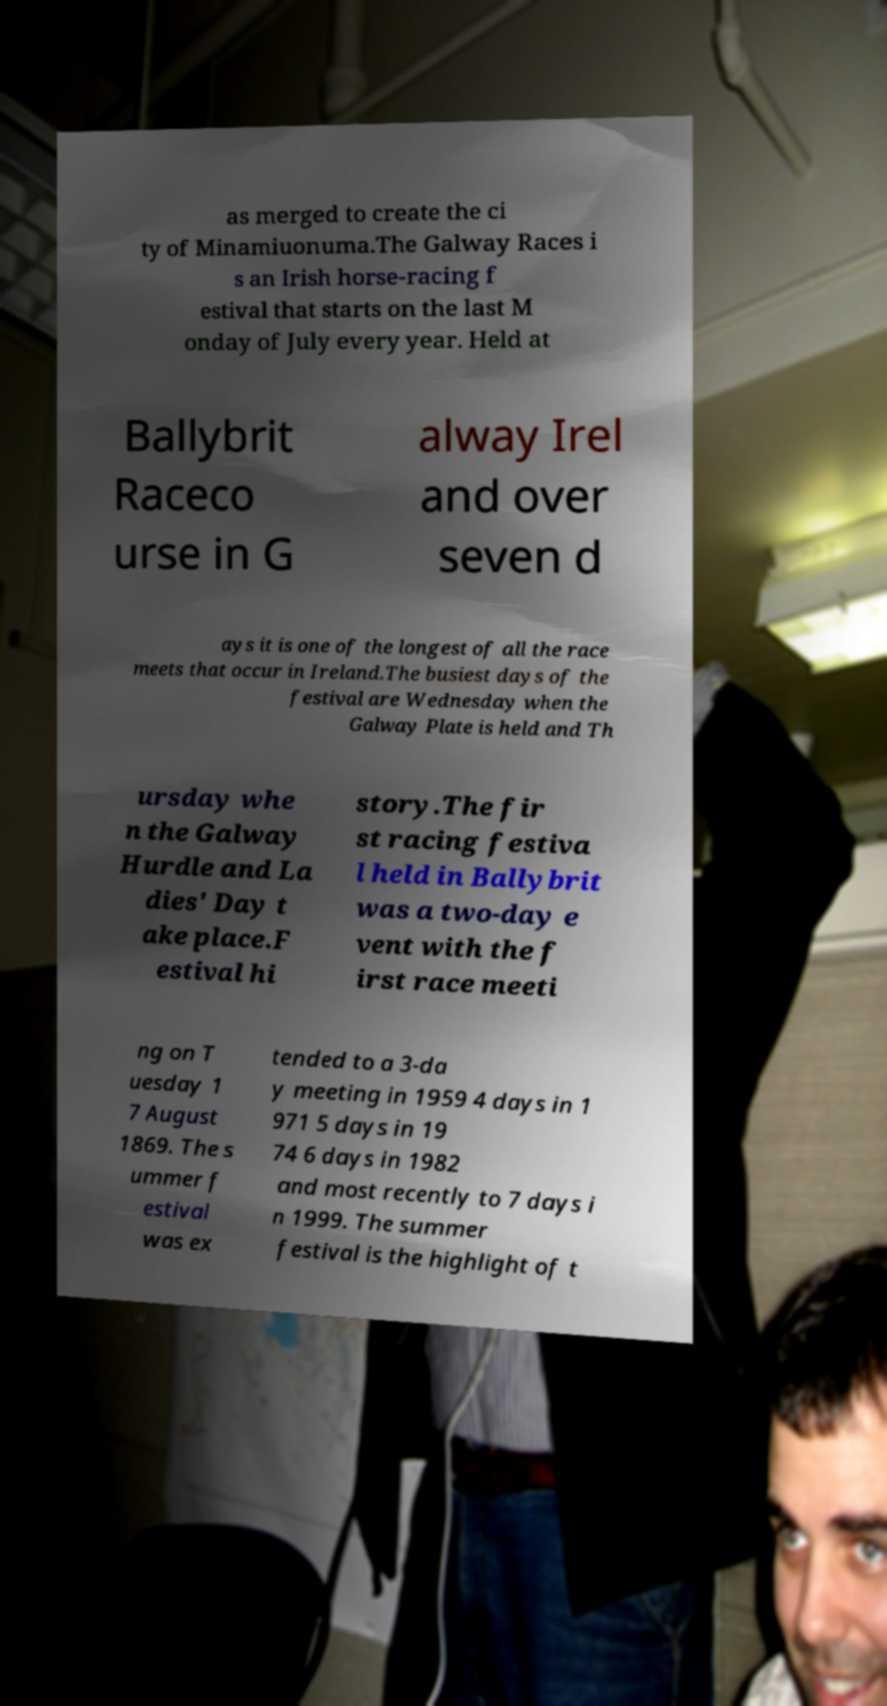There's text embedded in this image that I need extracted. Can you transcribe it verbatim? as merged to create the ci ty of Minamiuonuma.The Galway Races i s an Irish horse-racing f estival that starts on the last M onday of July every year. Held at Ballybrit Raceco urse in G alway Irel and over seven d ays it is one of the longest of all the race meets that occur in Ireland.The busiest days of the festival are Wednesday when the Galway Plate is held and Th ursday whe n the Galway Hurdle and La dies' Day t ake place.F estival hi story.The fir st racing festiva l held in Ballybrit was a two-day e vent with the f irst race meeti ng on T uesday 1 7 August 1869. The s ummer f estival was ex tended to a 3-da y meeting in 1959 4 days in 1 971 5 days in 19 74 6 days in 1982 and most recently to 7 days i n 1999. The summer festival is the highlight of t 